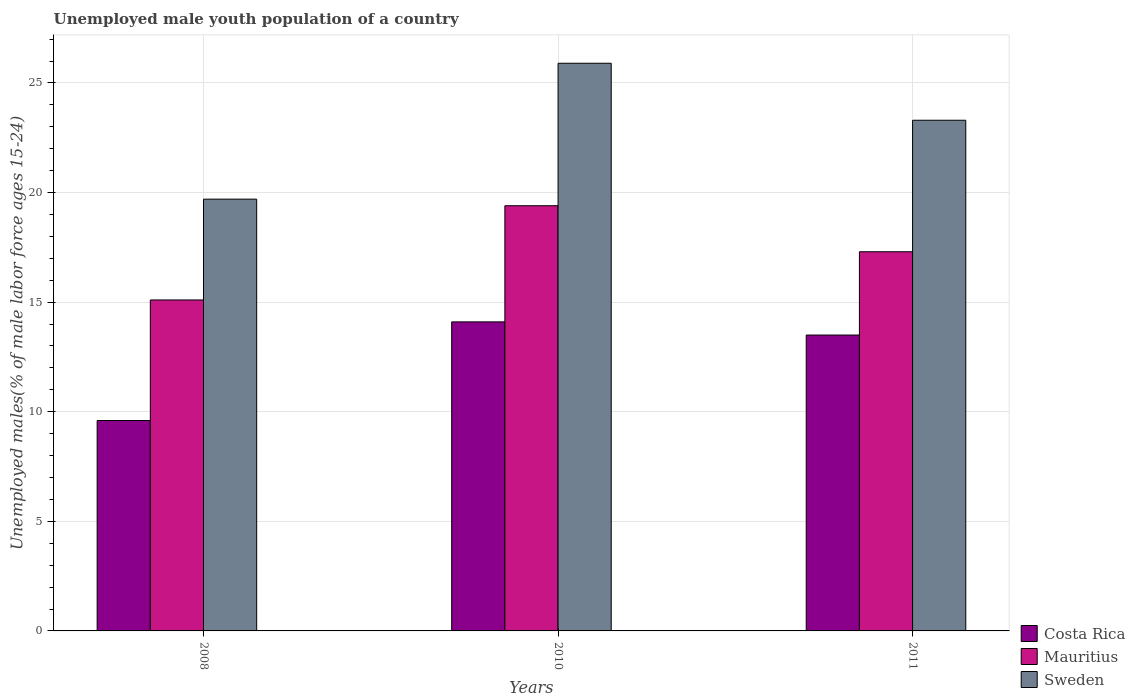How many different coloured bars are there?
Give a very brief answer. 3. How many groups of bars are there?
Provide a succinct answer. 3. How many bars are there on the 1st tick from the left?
Your answer should be compact. 3. What is the label of the 1st group of bars from the left?
Keep it short and to the point. 2008. What is the percentage of unemployed male youth population in Mauritius in 2008?
Your response must be concise. 15.1. Across all years, what is the maximum percentage of unemployed male youth population in Mauritius?
Your response must be concise. 19.4. Across all years, what is the minimum percentage of unemployed male youth population in Sweden?
Offer a terse response. 19.7. In which year was the percentage of unemployed male youth population in Costa Rica minimum?
Keep it short and to the point. 2008. What is the total percentage of unemployed male youth population in Mauritius in the graph?
Offer a terse response. 51.8. What is the difference between the percentage of unemployed male youth population in Sweden in 2008 and that in 2010?
Keep it short and to the point. -6.2. What is the difference between the percentage of unemployed male youth population in Costa Rica in 2011 and the percentage of unemployed male youth population in Sweden in 2010?
Keep it short and to the point. -12.4. What is the average percentage of unemployed male youth population in Mauritius per year?
Provide a short and direct response. 17.27. What is the ratio of the percentage of unemployed male youth population in Mauritius in 2008 to that in 2010?
Your response must be concise. 0.78. What is the difference between the highest and the second highest percentage of unemployed male youth population in Sweden?
Make the answer very short. 2.6. What is the difference between the highest and the lowest percentage of unemployed male youth population in Sweden?
Make the answer very short. 6.2. Is the sum of the percentage of unemployed male youth population in Costa Rica in 2008 and 2010 greater than the maximum percentage of unemployed male youth population in Mauritius across all years?
Your answer should be very brief. Yes. What does the 2nd bar from the left in 2008 represents?
Keep it short and to the point. Mauritius. What does the 2nd bar from the right in 2008 represents?
Your answer should be compact. Mauritius. Is it the case that in every year, the sum of the percentage of unemployed male youth population in Mauritius and percentage of unemployed male youth population in Sweden is greater than the percentage of unemployed male youth population in Costa Rica?
Give a very brief answer. Yes. How many bars are there?
Ensure brevity in your answer.  9. Are all the bars in the graph horizontal?
Make the answer very short. No. How many years are there in the graph?
Your answer should be very brief. 3. What is the difference between two consecutive major ticks on the Y-axis?
Your answer should be compact. 5. How are the legend labels stacked?
Provide a short and direct response. Vertical. What is the title of the graph?
Your answer should be very brief. Unemployed male youth population of a country. What is the label or title of the Y-axis?
Offer a terse response. Unemployed males(% of male labor force ages 15-24). What is the Unemployed males(% of male labor force ages 15-24) in Costa Rica in 2008?
Ensure brevity in your answer.  9.6. What is the Unemployed males(% of male labor force ages 15-24) of Mauritius in 2008?
Provide a succinct answer. 15.1. What is the Unemployed males(% of male labor force ages 15-24) of Sweden in 2008?
Your response must be concise. 19.7. What is the Unemployed males(% of male labor force ages 15-24) in Costa Rica in 2010?
Your answer should be compact. 14.1. What is the Unemployed males(% of male labor force ages 15-24) in Mauritius in 2010?
Offer a terse response. 19.4. What is the Unemployed males(% of male labor force ages 15-24) of Sweden in 2010?
Give a very brief answer. 25.9. What is the Unemployed males(% of male labor force ages 15-24) in Costa Rica in 2011?
Provide a short and direct response. 13.5. What is the Unemployed males(% of male labor force ages 15-24) of Mauritius in 2011?
Your answer should be compact. 17.3. What is the Unemployed males(% of male labor force ages 15-24) in Sweden in 2011?
Offer a terse response. 23.3. Across all years, what is the maximum Unemployed males(% of male labor force ages 15-24) in Costa Rica?
Keep it short and to the point. 14.1. Across all years, what is the maximum Unemployed males(% of male labor force ages 15-24) of Mauritius?
Make the answer very short. 19.4. Across all years, what is the maximum Unemployed males(% of male labor force ages 15-24) of Sweden?
Your answer should be compact. 25.9. Across all years, what is the minimum Unemployed males(% of male labor force ages 15-24) in Costa Rica?
Make the answer very short. 9.6. Across all years, what is the minimum Unemployed males(% of male labor force ages 15-24) of Mauritius?
Keep it short and to the point. 15.1. Across all years, what is the minimum Unemployed males(% of male labor force ages 15-24) in Sweden?
Make the answer very short. 19.7. What is the total Unemployed males(% of male labor force ages 15-24) in Costa Rica in the graph?
Offer a very short reply. 37.2. What is the total Unemployed males(% of male labor force ages 15-24) of Mauritius in the graph?
Your response must be concise. 51.8. What is the total Unemployed males(% of male labor force ages 15-24) of Sweden in the graph?
Make the answer very short. 68.9. What is the difference between the Unemployed males(% of male labor force ages 15-24) of Costa Rica in 2008 and that in 2010?
Give a very brief answer. -4.5. What is the difference between the Unemployed males(% of male labor force ages 15-24) in Mauritius in 2008 and that in 2010?
Give a very brief answer. -4.3. What is the difference between the Unemployed males(% of male labor force ages 15-24) in Sweden in 2008 and that in 2010?
Keep it short and to the point. -6.2. What is the difference between the Unemployed males(% of male labor force ages 15-24) in Costa Rica in 2008 and that in 2011?
Provide a succinct answer. -3.9. What is the difference between the Unemployed males(% of male labor force ages 15-24) in Sweden in 2008 and that in 2011?
Ensure brevity in your answer.  -3.6. What is the difference between the Unemployed males(% of male labor force ages 15-24) in Mauritius in 2010 and that in 2011?
Ensure brevity in your answer.  2.1. What is the difference between the Unemployed males(% of male labor force ages 15-24) of Costa Rica in 2008 and the Unemployed males(% of male labor force ages 15-24) of Mauritius in 2010?
Provide a short and direct response. -9.8. What is the difference between the Unemployed males(% of male labor force ages 15-24) in Costa Rica in 2008 and the Unemployed males(% of male labor force ages 15-24) in Sweden in 2010?
Give a very brief answer. -16.3. What is the difference between the Unemployed males(% of male labor force ages 15-24) of Costa Rica in 2008 and the Unemployed males(% of male labor force ages 15-24) of Sweden in 2011?
Make the answer very short. -13.7. What is the difference between the Unemployed males(% of male labor force ages 15-24) of Mauritius in 2008 and the Unemployed males(% of male labor force ages 15-24) of Sweden in 2011?
Offer a terse response. -8.2. What is the difference between the Unemployed males(% of male labor force ages 15-24) in Costa Rica in 2010 and the Unemployed males(% of male labor force ages 15-24) in Sweden in 2011?
Provide a short and direct response. -9.2. What is the difference between the Unemployed males(% of male labor force ages 15-24) of Mauritius in 2010 and the Unemployed males(% of male labor force ages 15-24) of Sweden in 2011?
Provide a succinct answer. -3.9. What is the average Unemployed males(% of male labor force ages 15-24) of Mauritius per year?
Provide a succinct answer. 17.27. What is the average Unemployed males(% of male labor force ages 15-24) of Sweden per year?
Provide a short and direct response. 22.97. In the year 2008, what is the difference between the Unemployed males(% of male labor force ages 15-24) in Costa Rica and Unemployed males(% of male labor force ages 15-24) in Mauritius?
Make the answer very short. -5.5. In the year 2008, what is the difference between the Unemployed males(% of male labor force ages 15-24) in Costa Rica and Unemployed males(% of male labor force ages 15-24) in Sweden?
Offer a very short reply. -10.1. In the year 2010, what is the difference between the Unemployed males(% of male labor force ages 15-24) in Costa Rica and Unemployed males(% of male labor force ages 15-24) in Mauritius?
Your answer should be compact. -5.3. In the year 2010, what is the difference between the Unemployed males(% of male labor force ages 15-24) in Costa Rica and Unemployed males(% of male labor force ages 15-24) in Sweden?
Ensure brevity in your answer.  -11.8. In the year 2010, what is the difference between the Unemployed males(% of male labor force ages 15-24) in Mauritius and Unemployed males(% of male labor force ages 15-24) in Sweden?
Make the answer very short. -6.5. What is the ratio of the Unemployed males(% of male labor force ages 15-24) of Costa Rica in 2008 to that in 2010?
Give a very brief answer. 0.68. What is the ratio of the Unemployed males(% of male labor force ages 15-24) in Mauritius in 2008 to that in 2010?
Your answer should be very brief. 0.78. What is the ratio of the Unemployed males(% of male labor force ages 15-24) of Sweden in 2008 to that in 2010?
Provide a short and direct response. 0.76. What is the ratio of the Unemployed males(% of male labor force ages 15-24) of Costa Rica in 2008 to that in 2011?
Your answer should be compact. 0.71. What is the ratio of the Unemployed males(% of male labor force ages 15-24) of Mauritius in 2008 to that in 2011?
Provide a short and direct response. 0.87. What is the ratio of the Unemployed males(% of male labor force ages 15-24) in Sweden in 2008 to that in 2011?
Ensure brevity in your answer.  0.85. What is the ratio of the Unemployed males(% of male labor force ages 15-24) in Costa Rica in 2010 to that in 2011?
Offer a terse response. 1.04. What is the ratio of the Unemployed males(% of male labor force ages 15-24) in Mauritius in 2010 to that in 2011?
Provide a succinct answer. 1.12. What is the ratio of the Unemployed males(% of male labor force ages 15-24) of Sweden in 2010 to that in 2011?
Give a very brief answer. 1.11. What is the difference between the highest and the second highest Unemployed males(% of male labor force ages 15-24) of Mauritius?
Provide a short and direct response. 2.1. What is the difference between the highest and the second highest Unemployed males(% of male labor force ages 15-24) of Sweden?
Your answer should be very brief. 2.6. What is the difference between the highest and the lowest Unemployed males(% of male labor force ages 15-24) of Mauritius?
Your answer should be compact. 4.3. 